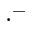Convert formula to latex. <formula><loc_0><loc_0><loc_500><loc_500>\cdot ^ { - }</formula> 